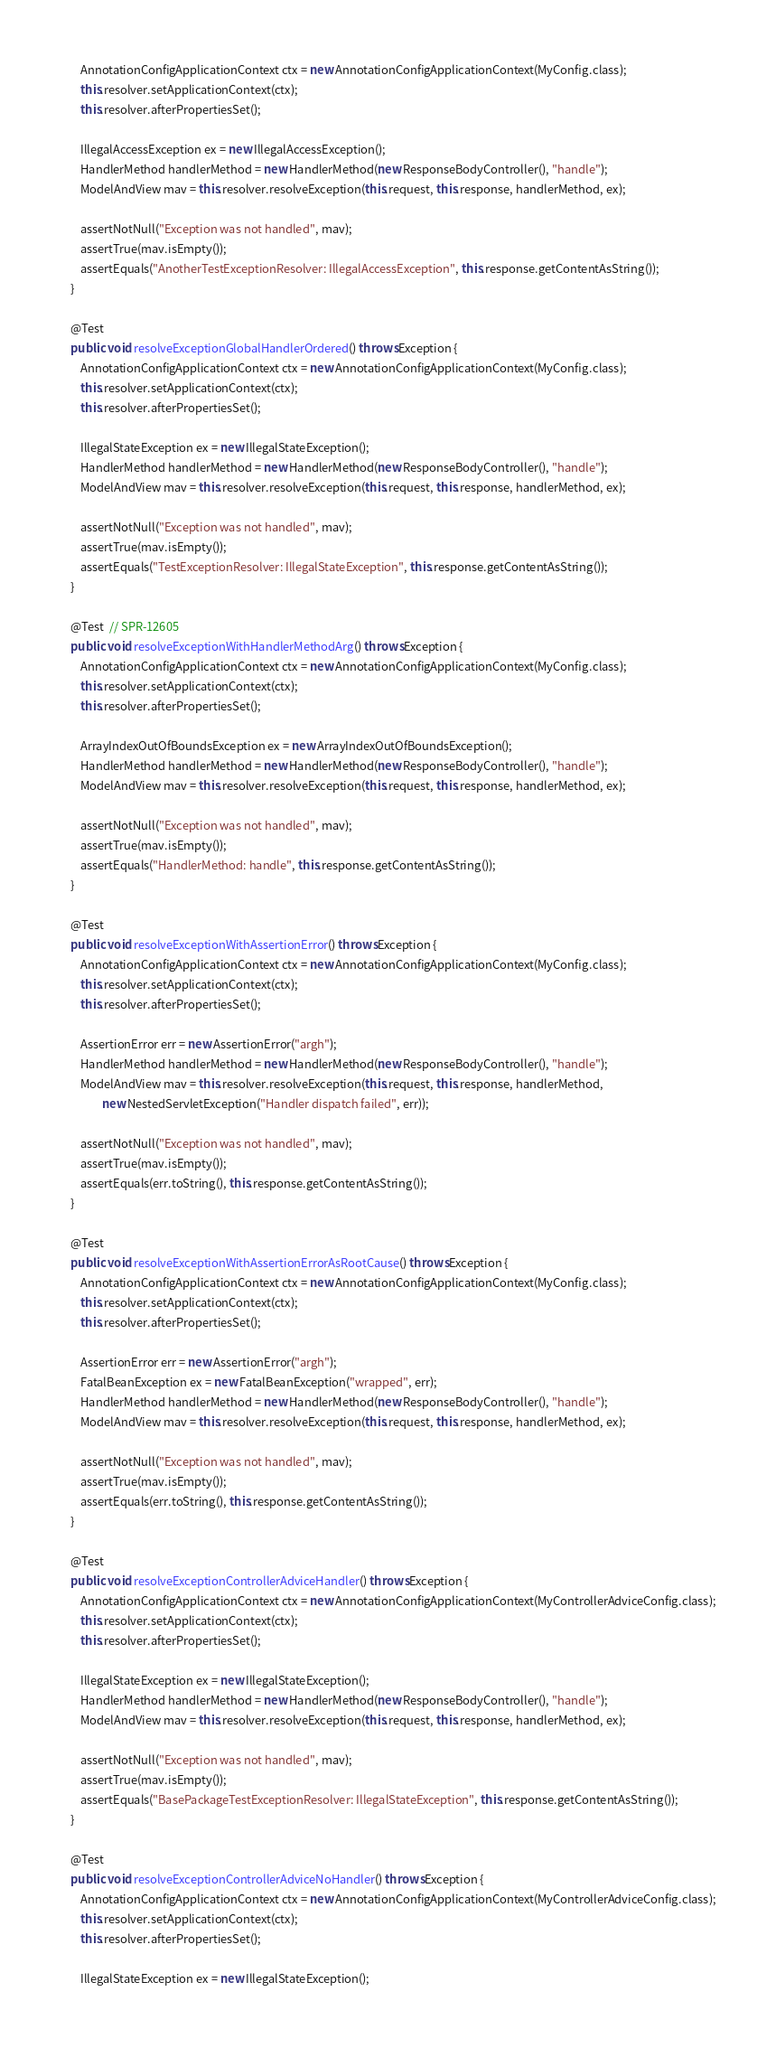Convert code to text. <code><loc_0><loc_0><loc_500><loc_500><_Java_>		AnnotationConfigApplicationContext ctx = new AnnotationConfigApplicationContext(MyConfig.class);
		this.resolver.setApplicationContext(ctx);
		this.resolver.afterPropertiesSet();

		IllegalAccessException ex = new IllegalAccessException();
		HandlerMethod handlerMethod = new HandlerMethod(new ResponseBodyController(), "handle");
		ModelAndView mav = this.resolver.resolveException(this.request, this.response, handlerMethod, ex);

		assertNotNull("Exception was not handled", mav);
		assertTrue(mav.isEmpty());
		assertEquals("AnotherTestExceptionResolver: IllegalAccessException", this.response.getContentAsString());
	}

	@Test
	public void resolveExceptionGlobalHandlerOrdered() throws Exception {
		AnnotationConfigApplicationContext ctx = new AnnotationConfigApplicationContext(MyConfig.class);
		this.resolver.setApplicationContext(ctx);
		this.resolver.afterPropertiesSet();

		IllegalStateException ex = new IllegalStateException();
		HandlerMethod handlerMethod = new HandlerMethod(new ResponseBodyController(), "handle");
		ModelAndView mav = this.resolver.resolveException(this.request, this.response, handlerMethod, ex);

		assertNotNull("Exception was not handled", mav);
		assertTrue(mav.isEmpty());
		assertEquals("TestExceptionResolver: IllegalStateException", this.response.getContentAsString());
	}

	@Test  // SPR-12605
	public void resolveExceptionWithHandlerMethodArg() throws Exception {
		AnnotationConfigApplicationContext ctx = new AnnotationConfigApplicationContext(MyConfig.class);
		this.resolver.setApplicationContext(ctx);
		this.resolver.afterPropertiesSet();

		ArrayIndexOutOfBoundsException ex = new ArrayIndexOutOfBoundsException();
		HandlerMethod handlerMethod = new HandlerMethod(new ResponseBodyController(), "handle");
		ModelAndView mav = this.resolver.resolveException(this.request, this.response, handlerMethod, ex);

		assertNotNull("Exception was not handled", mav);
		assertTrue(mav.isEmpty());
		assertEquals("HandlerMethod: handle", this.response.getContentAsString());
	}

	@Test
	public void resolveExceptionWithAssertionError() throws Exception {
		AnnotationConfigApplicationContext ctx = new AnnotationConfigApplicationContext(MyConfig.class);
		this.resolver.setApplicationContext(ctx);
		this.resolver.afterPropertiesSet();

		AssertionError err = new AssertionError("argh");
		HandlerMethod handlerMethod = new HandlerMethod(new ResponseBodyController(), "handle");
		ModelAndView mav = this.resolver.resolveException(this.request, this.response, handlerMethod,
				new NestedServletException("Handler dispatch failed", err));

		assertNotNull("Exception was not handled", mav);
		assertTrue(mav.isEmpty());
		assertEquals(err.toString(), this.response.getContentAsString());
	}

	@Test
	public void resolveExceptionWithAssertionErrorAsRootCause() throws Exception {
		AnnotationConfigApplicationContext ctx = new AnnotationConfigApplicationContext(MyConfig.class);
		this.resolver.setApplicationContext(ctx);
		this.resolver.afterPropertiesSet();

		AssertionError err = new AssertionError("argh");
		FatalBeanException ex = new FatalBeanException("wrapped", err);
		HandlerMethod handlerMethod = new HandlerMethod(new ResponseBodyController(), "handle");
		ModelAndView mav = this.resolver.resolveException(this.request, this.response, handlerMethod, ex);

		assertNotNull("Exception was not handled", mav);
		assertTrue(mav.isEmpty());
		assertEquals(err.toString(), this.response.getContentAsString());
	}

	@Test
	public void resolveExceptionControllerAdviceHandler() throws Exception {
		AnnotationConfigApplicationContext ctx = new AnnotationConfigApplicationContext(MyControllerAdviceConfig.class);
		this.resolver.setApplicationContext(ctx);
		this.resolver.afterPropertiesSet();

		IllegalStateException ex = new IllegalStateException();
		HandlerMethod handlerMethod = new HandlerMethod(new ResponseBodyController(), "handle");
		ModelAndView mav = this.resolver.resolveException(this.request, this.response, handlerMethod, ex);

		assertNotNull("Exception was not handled", mav);
		assertTrue(mav.isEmpty());
		assertEquals("BasePackageTestExceptionResolver: IllegalStateException", this.response.getContentAsString());
	}

	@Test
	public void resolveExceptionControllerAdviceNoHandler() throws Exception {
		AnnotationConfigApplicationContext ctx = new AnnotationConfigApplicationContext(MyControllerAdviceConfig.class);
		this.resolver.setApplicationContext(ctx);
		this.resolver.afterPropertiesSet();

		IllegalStateException ex = new IllegalStateException();</code> 